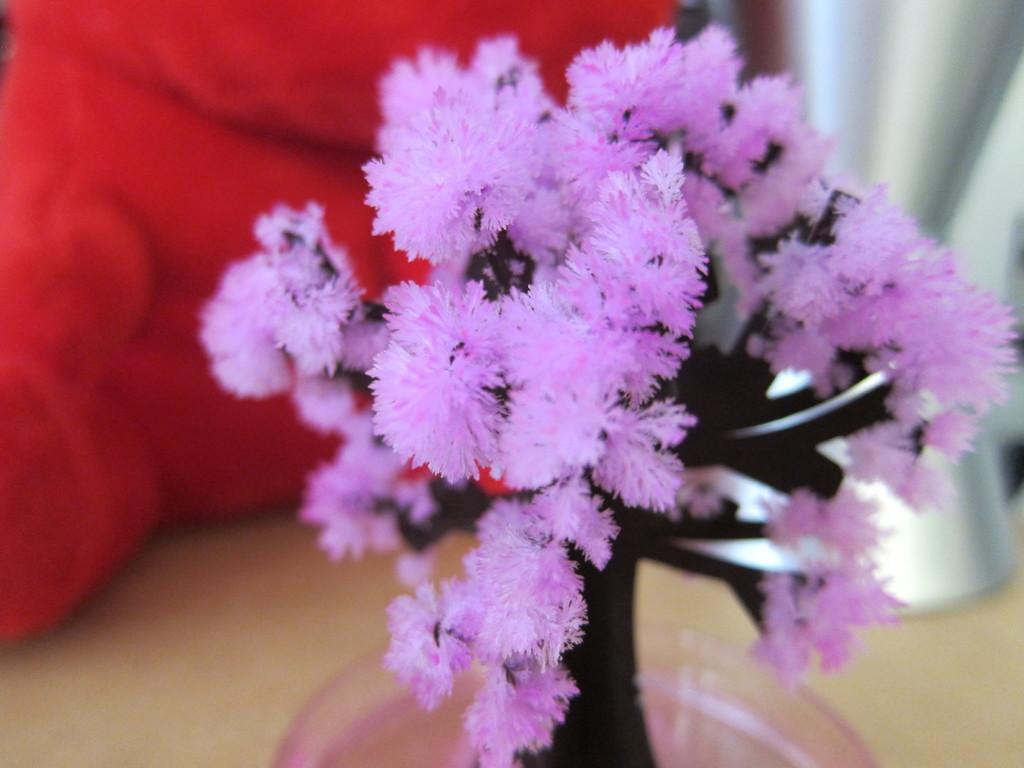Could you give a brief overview of what you see in this image? In the image there is an artificial tree with purple leaves and the background of the tree is blur. 